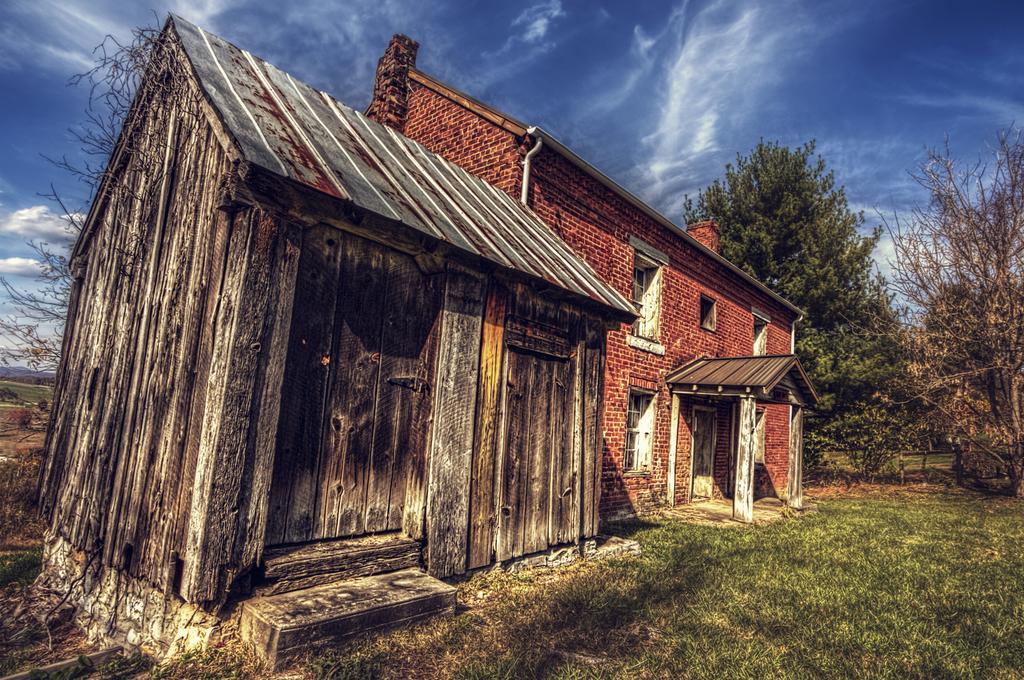Could you give a brief overview of what you see in this image? In front of the image there are houses. At the bottom of the image there is grass on the surface. In the background of the image there are trees. At the top of the image there is sky. 